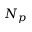Convert formula to latex. <formula><loc_0><loc_0><loc_500><loc_500>N _ { p }</formula> 